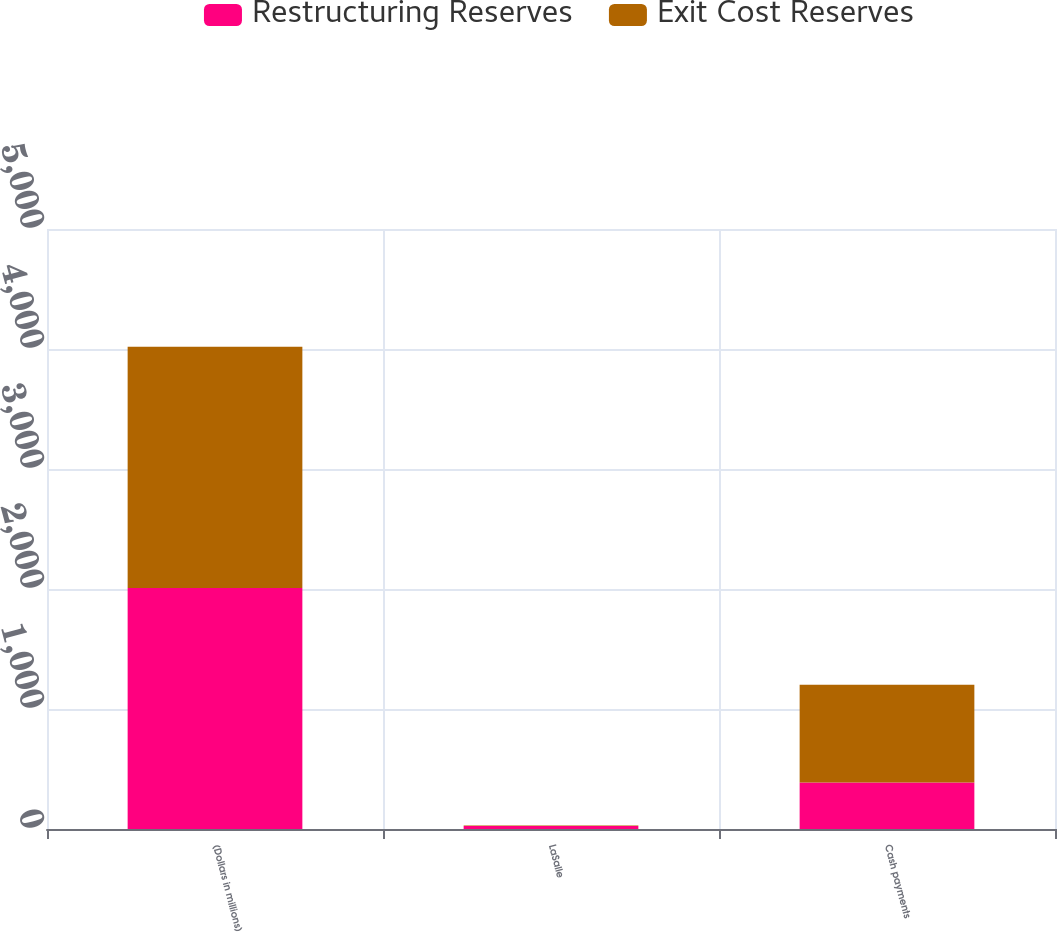Convert chart. <chart><loc_0><loc_0><loc_500><loc_500><stacked_bar_chart><ecel><fcel>(Dollars in millions)<fcel>LaSalle<fcel>Cash payments<nl><fcel>Restructuring Reserves<fcel>2009<fcel>24<fcel>387<nl><fcel>Exit Cost Reserves<fcel>2009<fcel>6<fcel>816<nl></chart> 